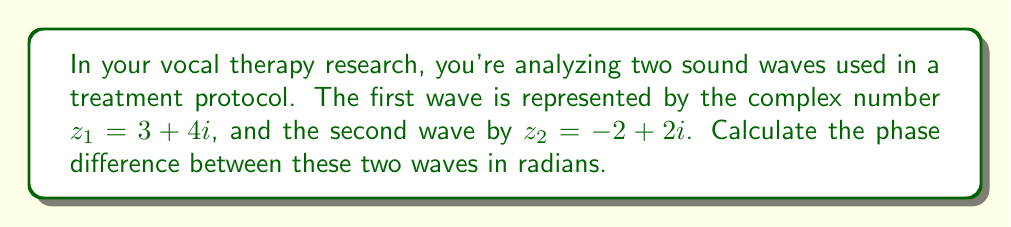Give your solution to this math problem. To find the phase difference between two complex numbers representing sound waves, we need to:

1. Calculate the argument (angle) of each complex number
2. Subtract the arguments to find the phase difference

Step 1: Calculate the arguments

For $z_1 = 3 + 4i$:
$$\arg(z_1) = \tan^{-1}\left(\frac{\text{Im}(z_1)}{\text{Re}(z_1)}\right) = \tan^{-1}\left(\frac{4}{3}\right) \approx 0.9273 \text{ radians}$$

For $z_2 = -2 + 2i$:
$$\arg(z_2) = \tan^{-1}\left(\frac{\text{Im}(z_2)}{\text{Re}(z_2)}\right) + \pi = \tan^{-1}\left(\frac{2}{-2}\right) + \pi = -\frac{\pi}{4} + \pi \approx 2.3562 \text{ radians}$$

Note: We add $\pi$ to the result for $z_2$ because it's in the second quadrant.

Step 2: Calculate the phase difference

Phase difference = $\arg(z_2) - \arg(z_1)$
$$= 2.3562 - 0.9273 \approx 1.4289 \text{ radians}$$

This result represents the phase difference between the two sound waves in radians.
Answer: $1.4289 \text{ radians}$ 